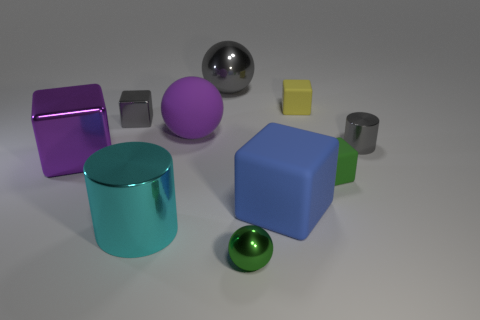Is the tiny green rubber object the same shape as the purple shiny object?
Make the answer very short. Yes. How many tiny rubber blocks are left of the large shiny sphere that is behind the gray object that is on the left side of the big purple rubber object?
Offer a very short reply. 0. The small object that is left of the big blue object and behind the tiny green rubber block is made of what material?
Ensure brevity in your answer.  Metal. What is the color of the cube that is to the left of the large gray shiny object and in front of the rubber sphere?
Ensure brevity in your answer.  Purple. Are there any other things that are the same color as the large metallic cylinder?
Your response must be concise. No. What shape is the large purple object to the right of the large object that is in front of the big object that is to the right of the green shiny sphere?
Keep it short and to the point. Sphere. There is a small metallic object that is the same shape as the small yellow rubber thing; what color is it?
Offer a very short reply. Gray. There is a metallic block left of the tiny cube on the left side of the big cyan metal cylinder; what color is it?
Keep it short and to the point. Purple. What is the size of the yellow thing that is the same shape as the big blue matte object?
Provide a short and direct response. Small. How many big cylinders have the same material as the green sphere?
Keep it short and to the point. 1. 